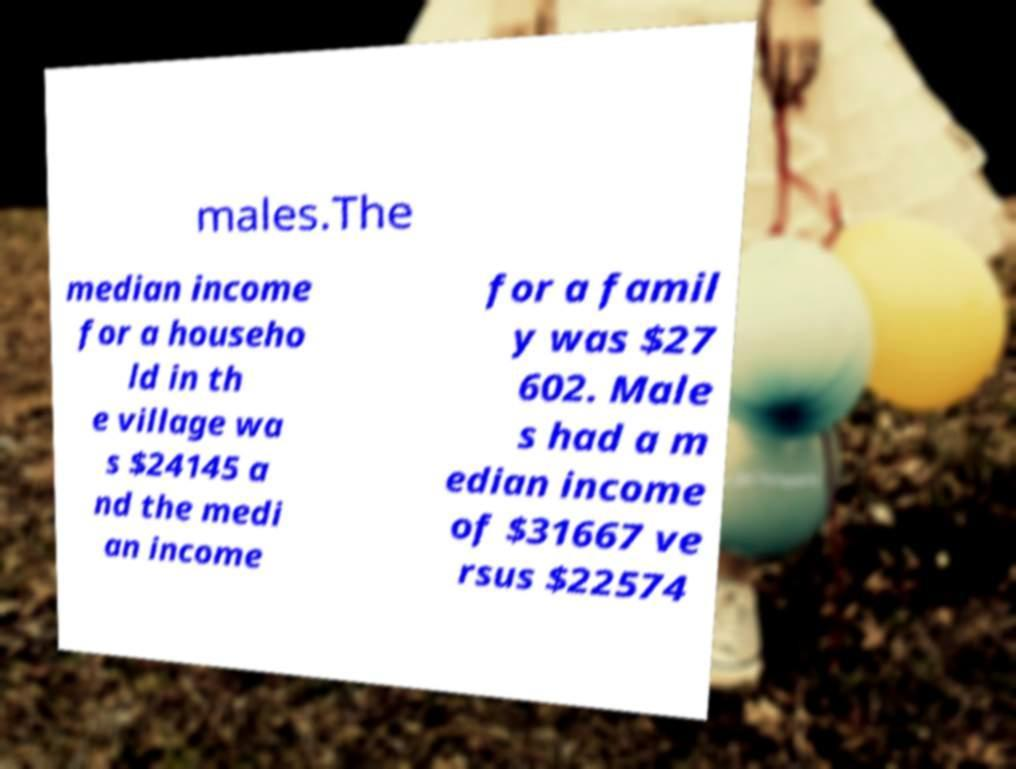For documentation purposes, I need the text within this image transcribed. Could you provide that? males.The median income for a househo ld in th e village wa s $24145 a nd the medi an income for a famil y was $27 602. Male s had a m edian income of $31667 ve rsus $22574 